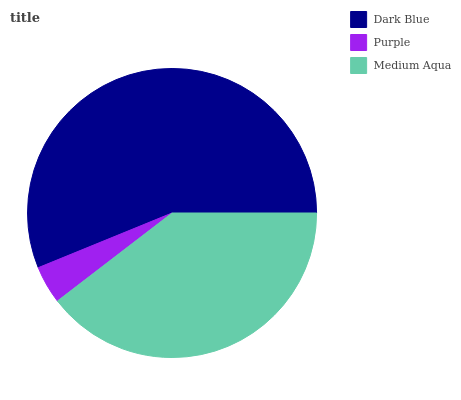Is Purple the minimum?
Answer yes or no. Yes. Is Dark Blue the maximum?
Answer yes or no. Yes. Is Medium Aqua the minimum?
Answer yes or no. No. Is Medium Aqua the maximum?
Answer yes or no. No. Is Medium Aqua greater than Purple?
Answer yes or no. Yes. Is Purple less than Medium Aqua?
Answer yes or no. Yes. Is Purple greater than Medium Aqua?
Answer yes or no. No. Is Medium Aqua less than Purple?
Answer yes or no. No. Is Medium Aqua the high median?
Answer yes or no. Yes. Is Medium Aqua the low median?
Answer yes or no. Yes. Is Purple the high median?
Answer yes or no. No. Is Dark Blue the low median?
Answer yes or no. No. 